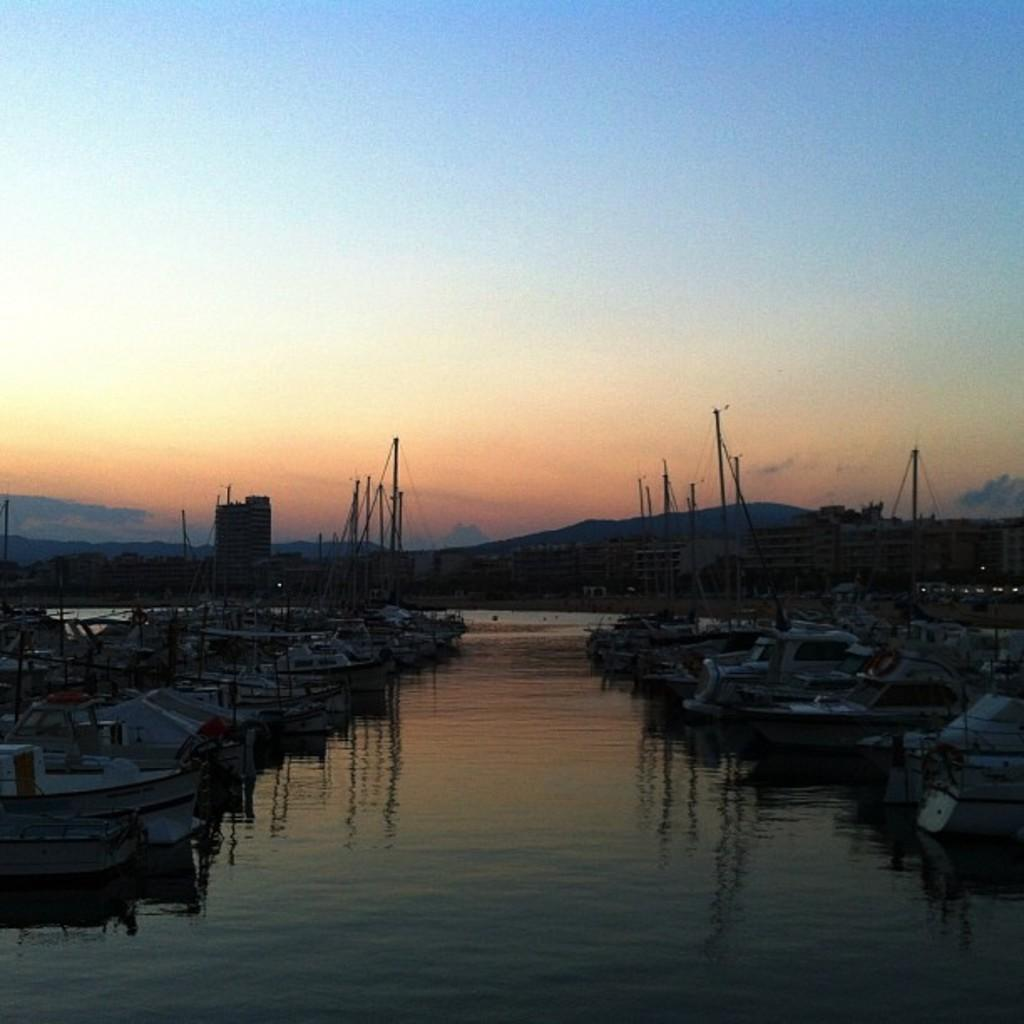What is in the water in the image? There are boats in the water in the image. What type of structures can be seen in the image? There are buildings visible in the image. What natural feature is present in the image? There are mountains in the image. What color is the sky in the image? The sky is blue in the image. Where is the aunt in the image? There is no aunt present in the image. What type of drawer can be seen in the image? There is no drawer present in the image. 